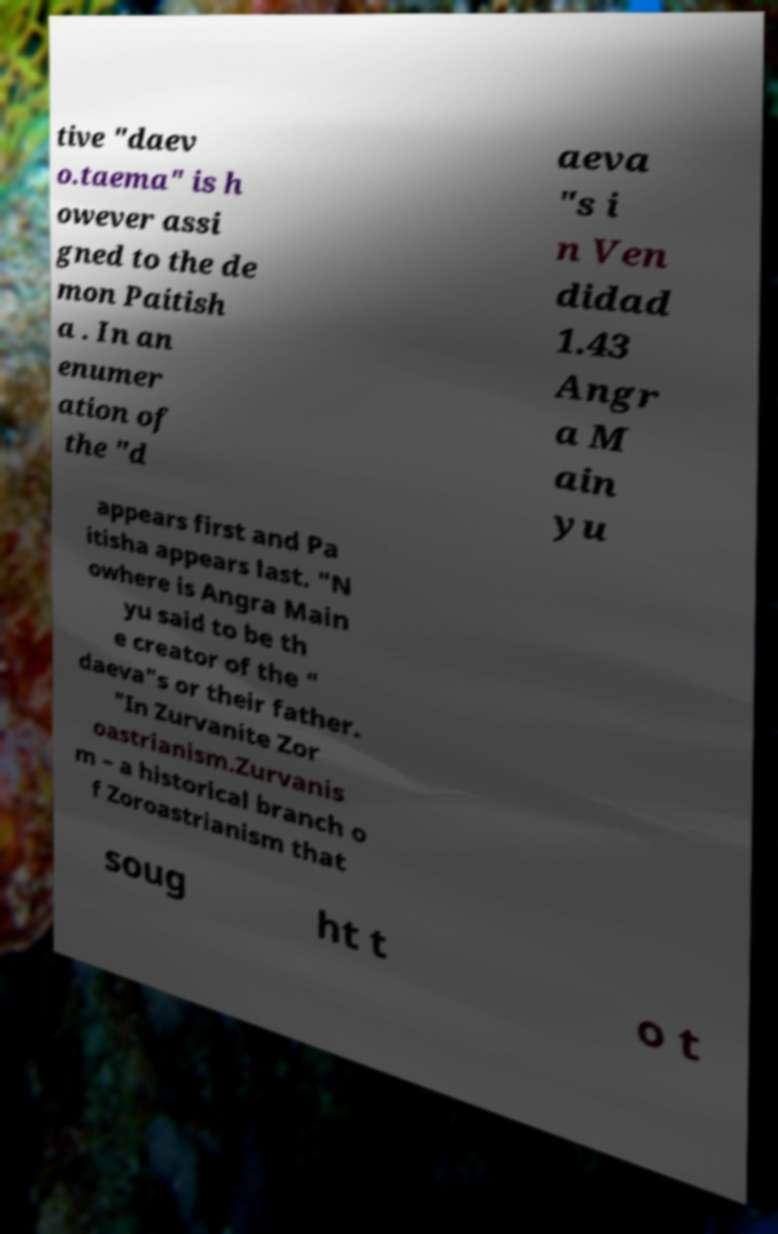I need the written content from this picture converted into text. Can you do that? tive "daev o.taema" is h owever assi gned to the de mon Paitish a . In an enumer ation of the "d aeva "s i n Ven didad 1.43 Angr a M ain yu appears first and Pa itisha appears last. "N owhere is Angra Main yu said to be th e creator of the " daeva"s or their father. "In Zurvanite Zor oastrianism.Zurvanis m – a historical branch o f Zoroastrianism that soug ht t o t 